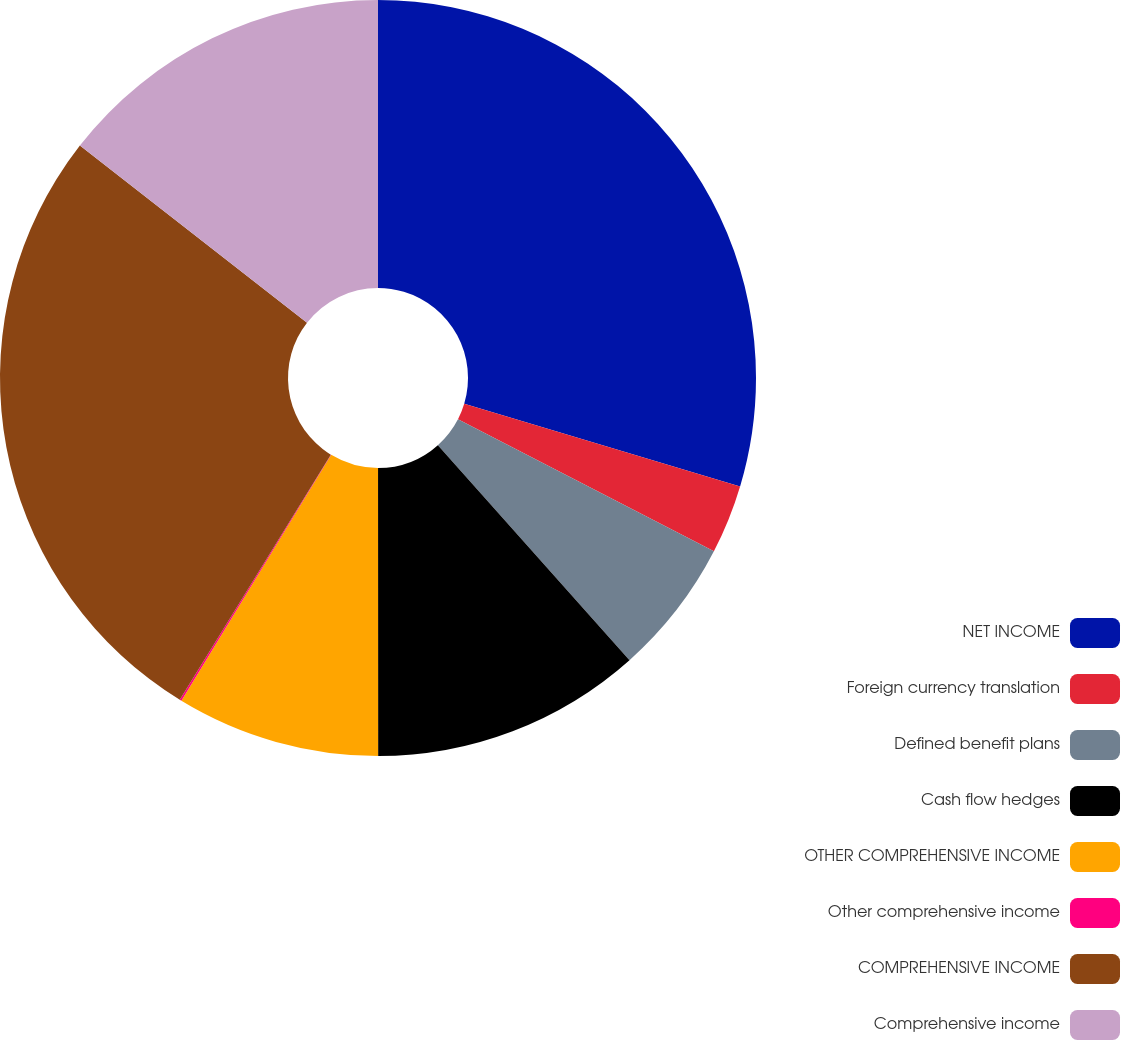<chart> <loc_0><loc_0><loc_500><loc_500><pie_chart><fcel>NET INCOME<fcel>Foreign currency translation<fcel>Defined benefit plans<fcel>Cash flow hedges<fcel>OTHER COMPREHENSIVE INCOME<fcel>Other comprehensive income<fcel>COMPREHENSIVE INCOME<fcel>Comprehensive income<nl><fcel>29.63%<fcel>2.95%<fcel>5.83%<fcel>11.58%<fcel>8.71%<fcel>0.08%<fcel>26.75%<fcel>14.46%<nl></chart> 